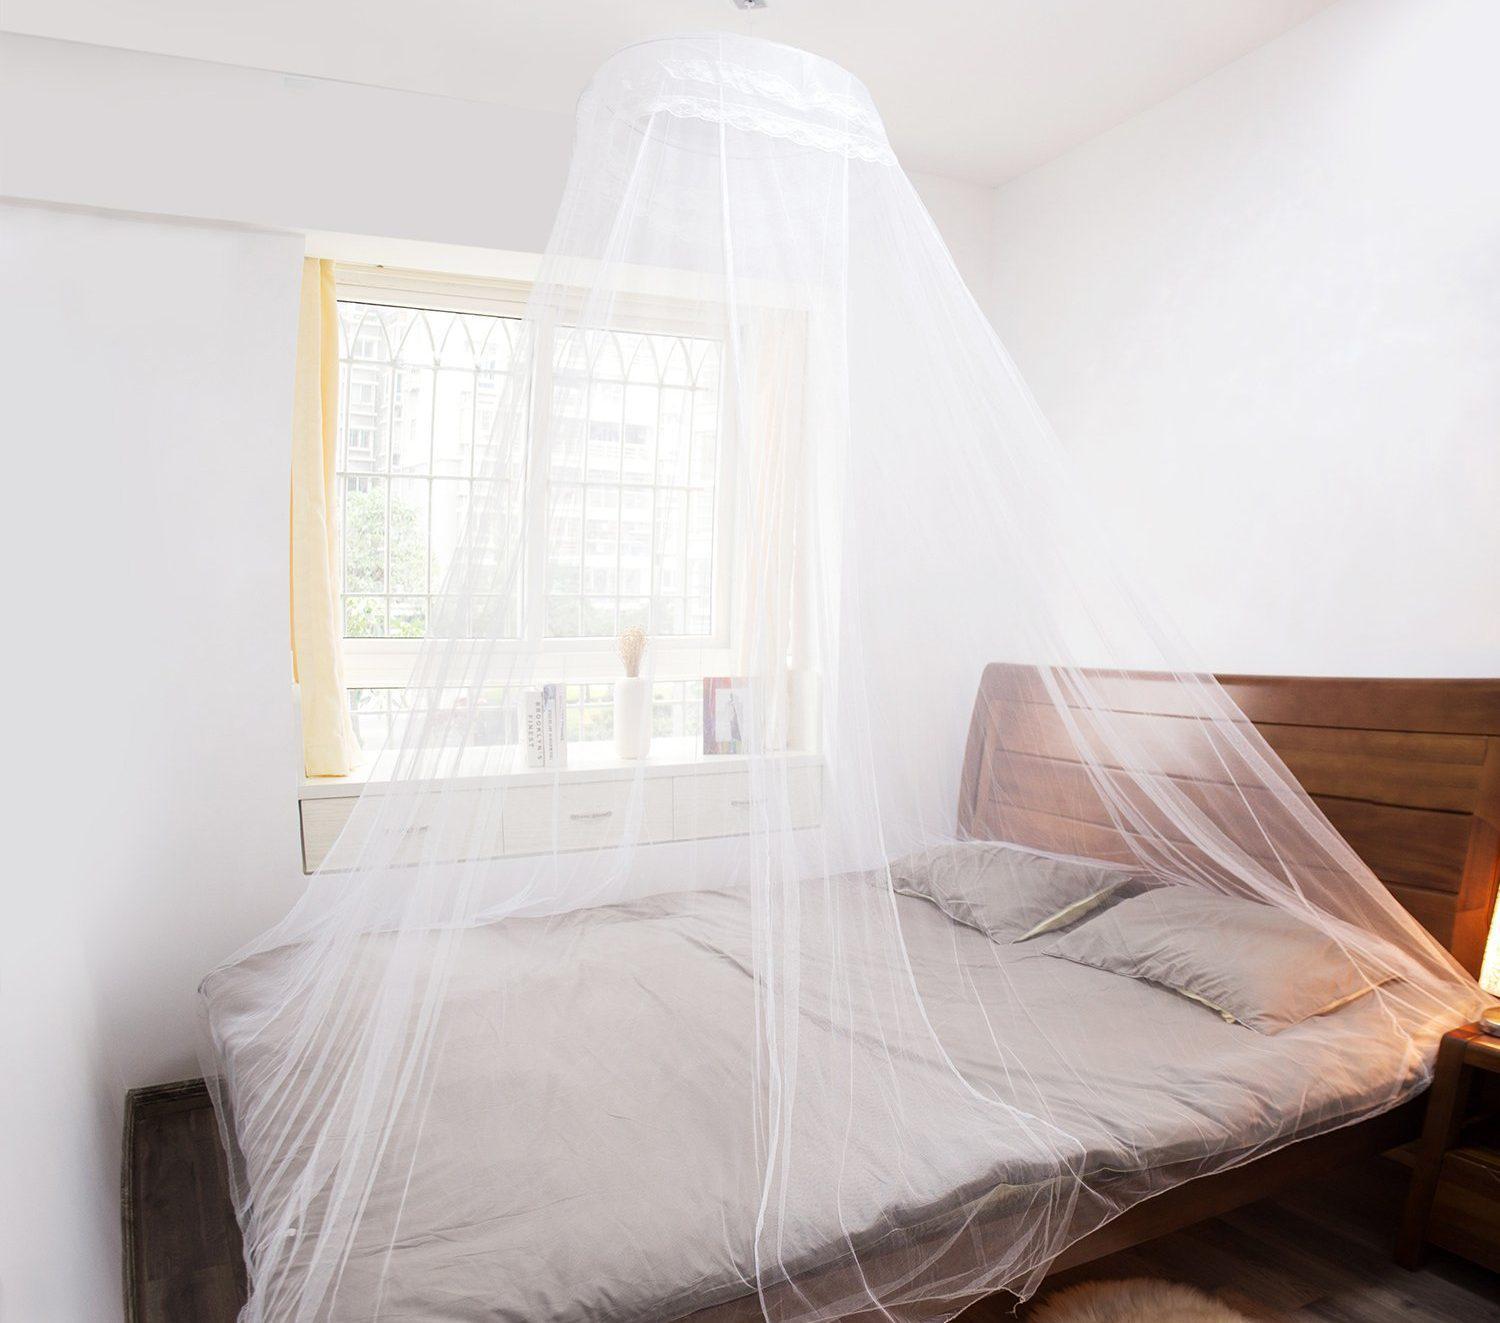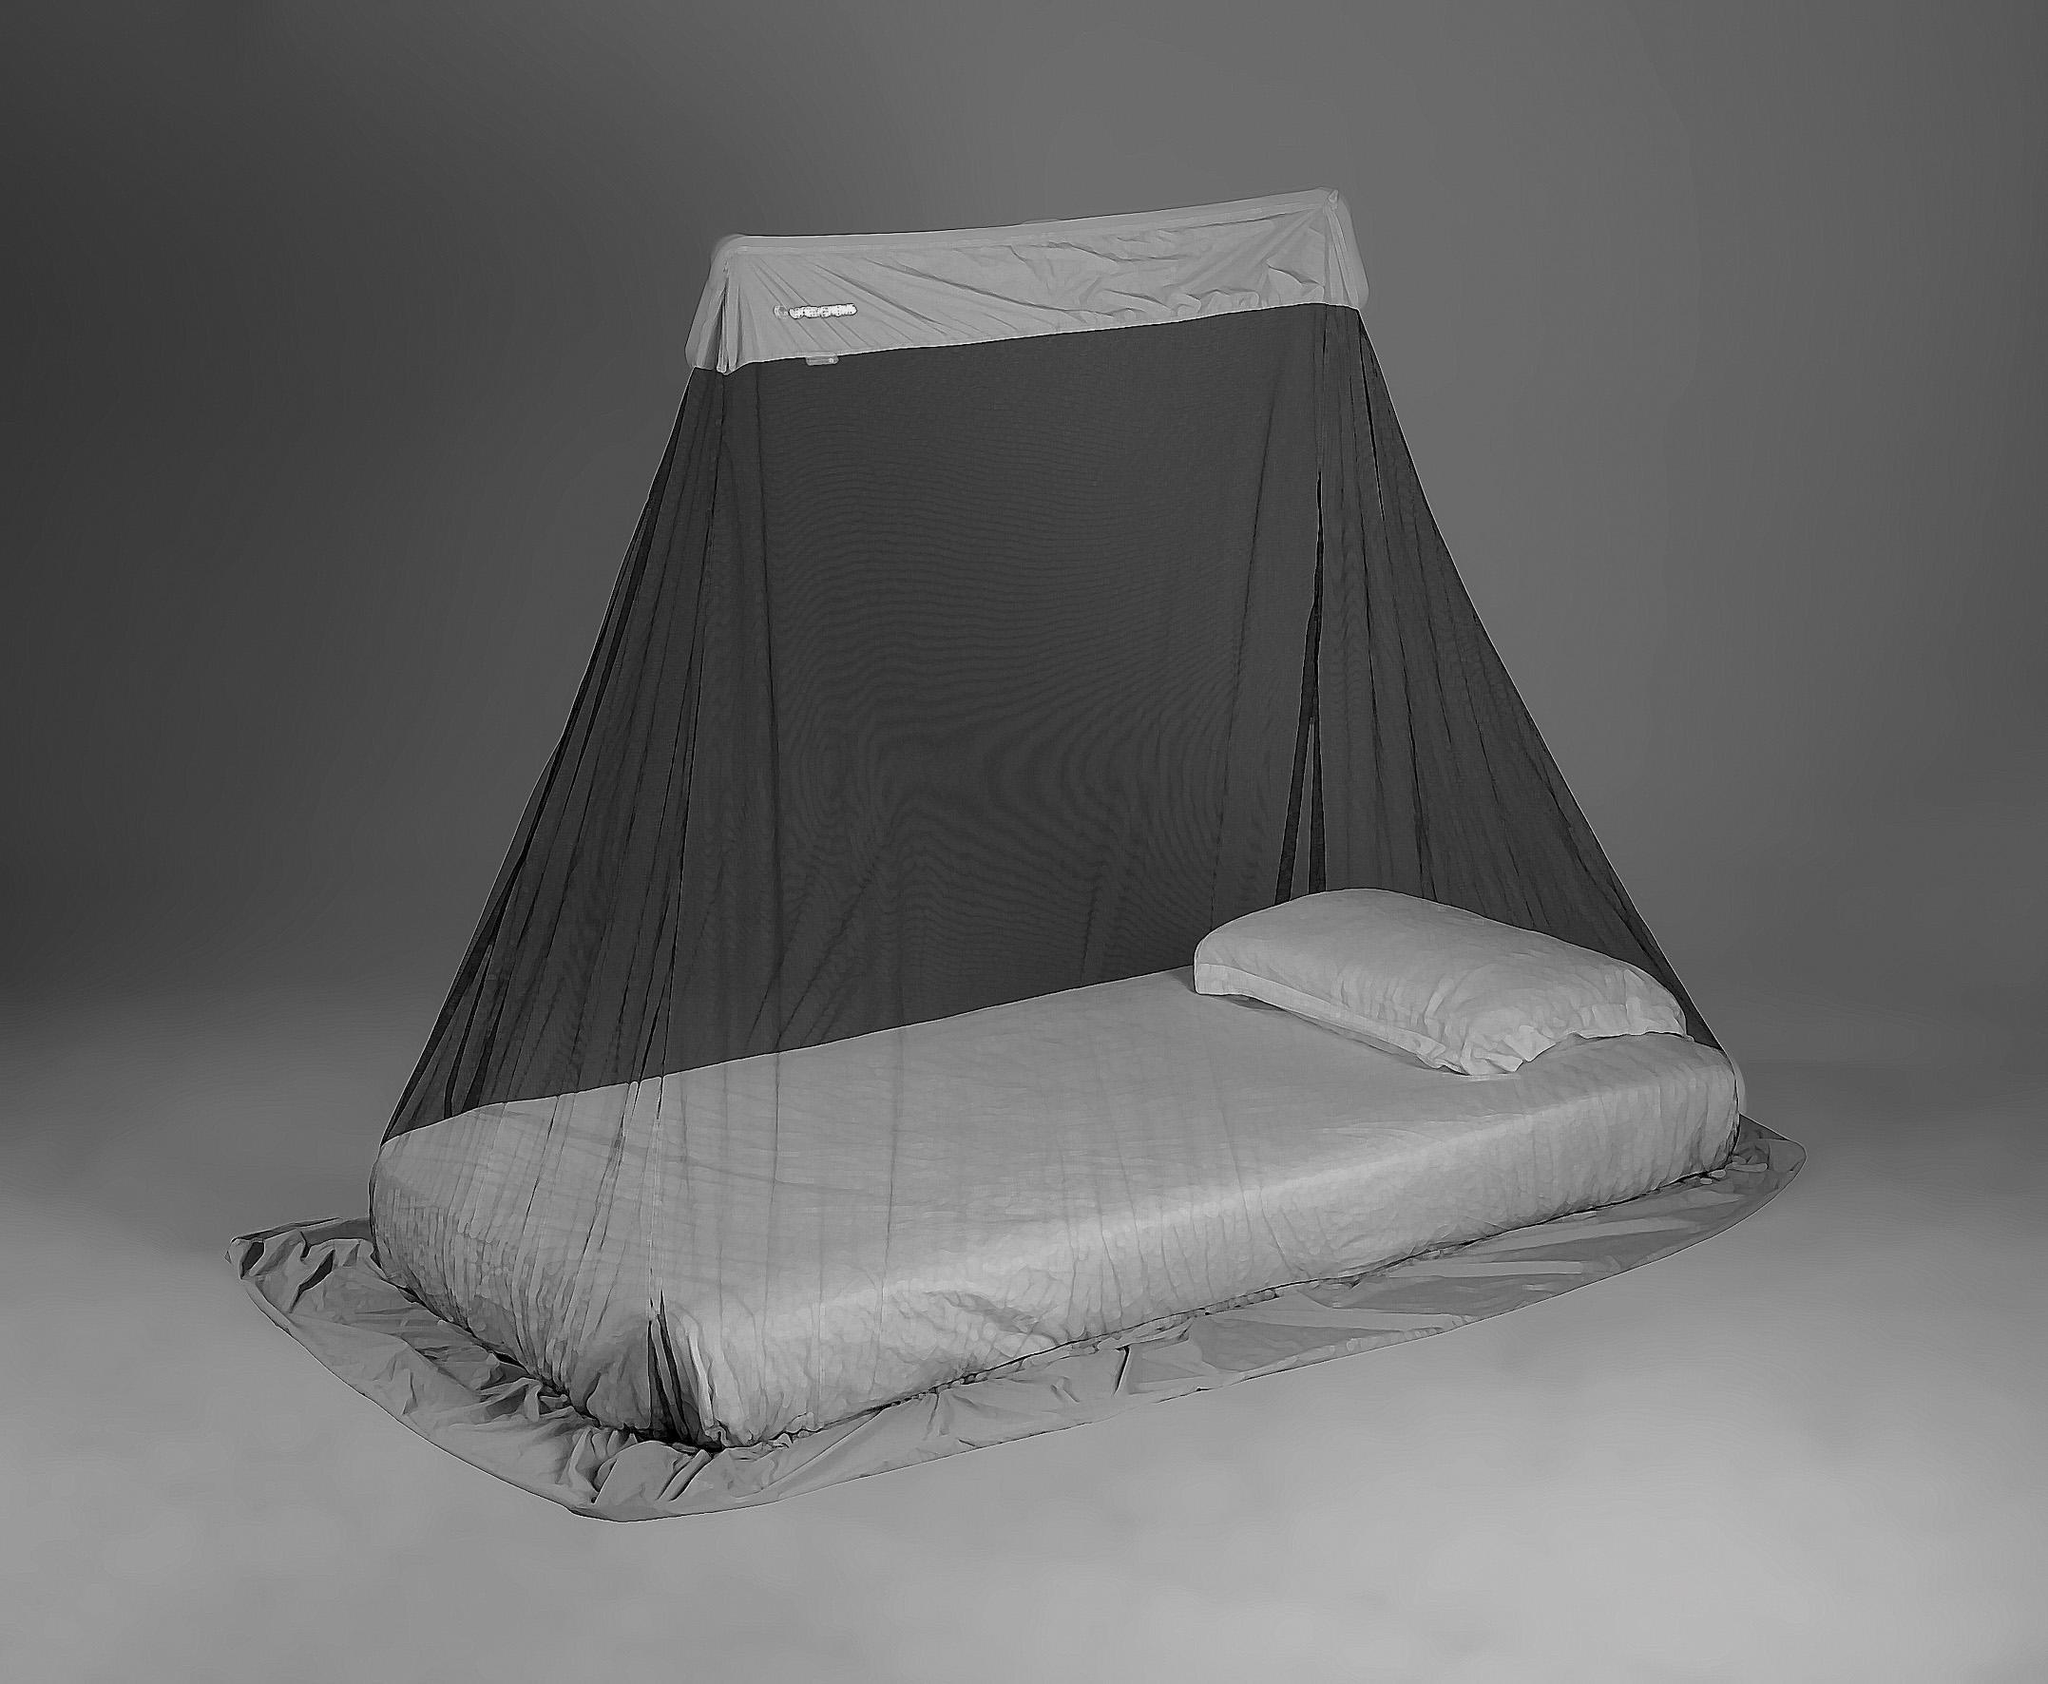The first image is the image on the left, the second image is the image on the right. Given the left and right images, does the statement "There are two circle canopies." hold true? Answer yes or no. No. The first image is the image on the left, the second image is the image on the right. Considering the images on both sides, is "In the left image, you can see the entire window; the window top, bottom and both sides are clearly visible." valid? Answer yes or no. Yes. 